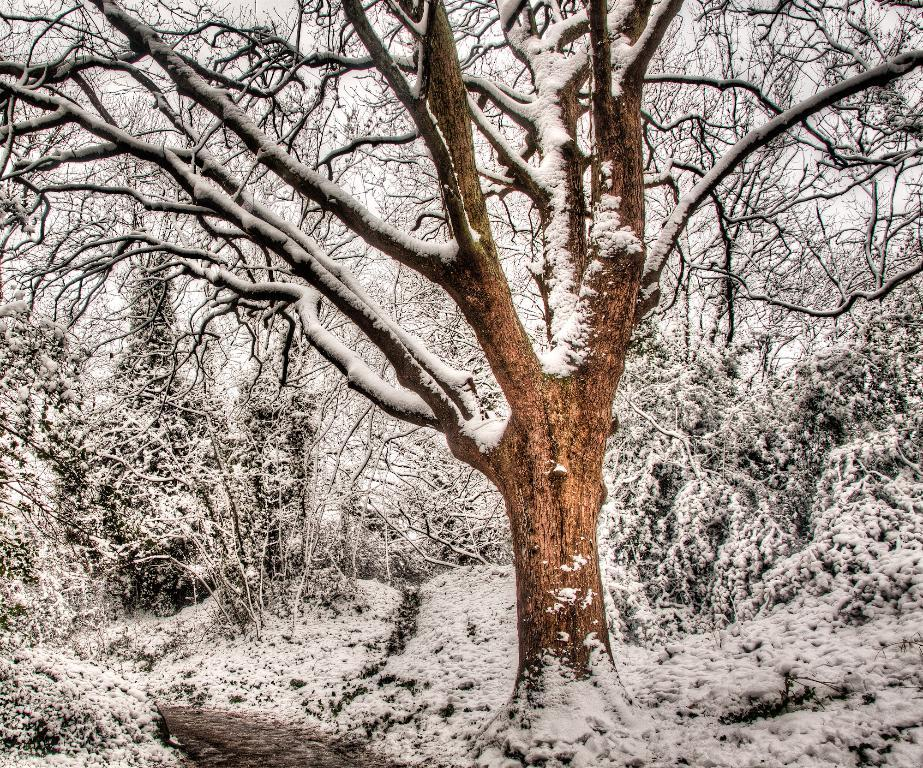What is the condition of the trees in the image? The trees in the image are covered with snow. Can you describe the appearance of a specific tree in the image? A bark of a tree is covered with snow. What can be seen in the background of the image? The sky is visible in the background of the image. What type of bell can be seen hanging from the branches of the trees in the image? There is no bell present in the image; the trees are covered with snow. How is the chalk used in the image? There is no chalk present in the image. 